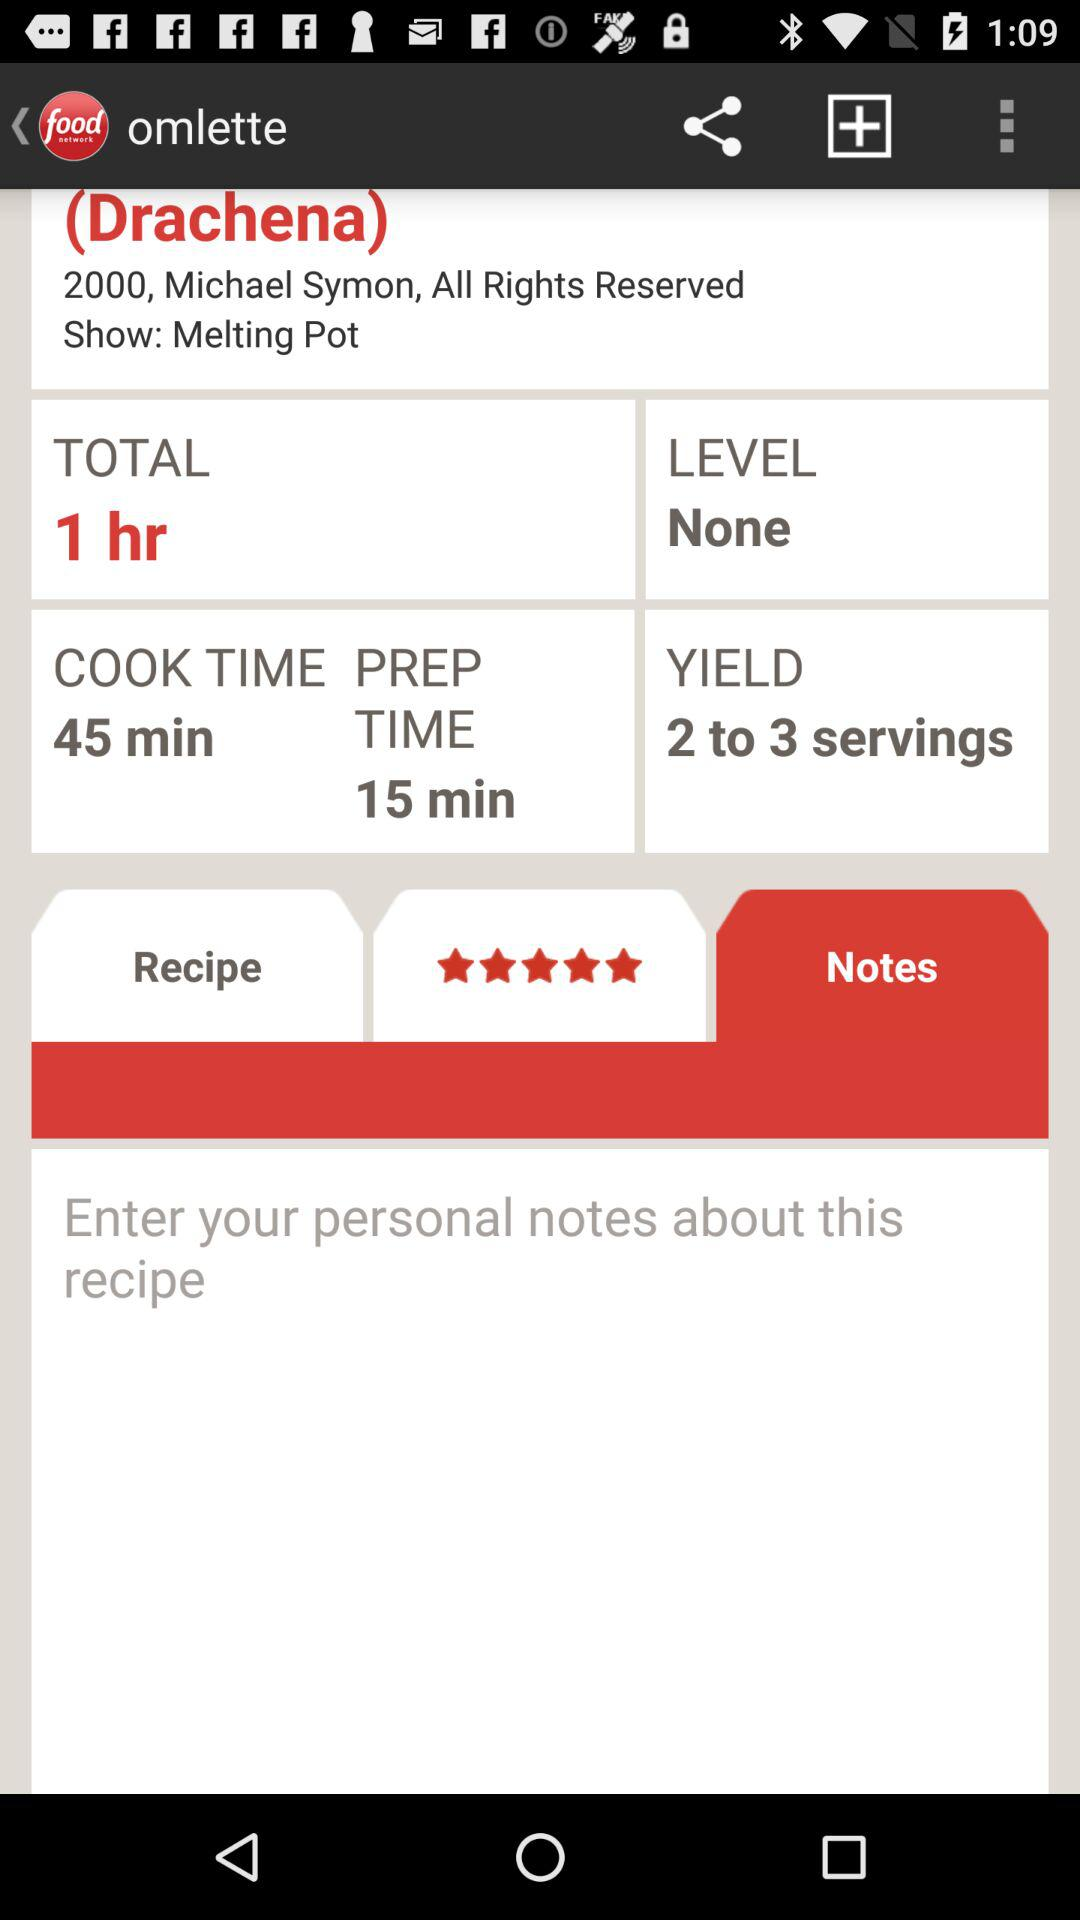What is the total time? The total time is 1 hour. 